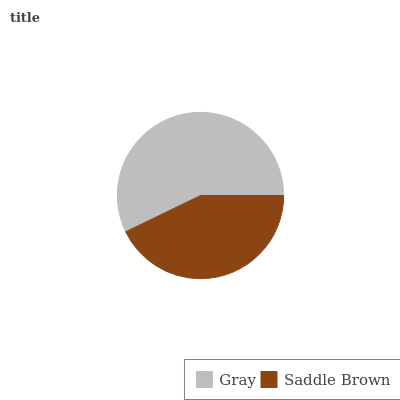Is Saddle Brown the minimum?
Answer yes or no. Yes. Is Gray the maximum?
Answer yes or no. Yes. Is Saddle Brown the maximum?
Answer yes or no. No. Is Gray greater than Saddle Brown?
Answer yes or no. Yes. Is Saddle Brown less than Gray?
Answer yes or no. Yes. Is Saddle Brown greater than Gray?
Answer yes or no. No. Is Gray less than Saddle Brown?
Answer yes or no. No. Is Gray the high median?
Answer yes or no. Yes. Is Saddle Brown the low median?
Answer yes or no. Yes. Is Saddle Brown the high median?
Answer yes or no. No. Is Gray the low median?
Answer yes or no. No. 